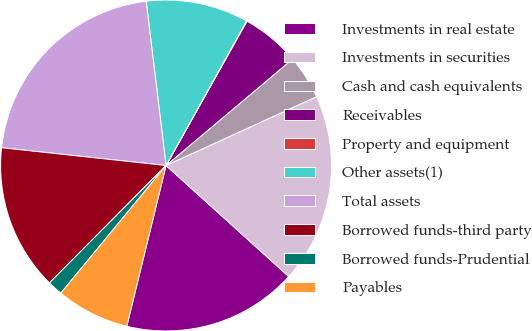<chart> <loc_0><loc_0><loc_500><loc_500><pie_chart><fcel>Investments in real estate<fcel>Investments in securities<fcel>Cash and cash equivalents<fcel>Receivables<fcel>Property and equipment<fcel>Other assets(1)<fcel>Total assets<fcel>Borrowed funds-third party<fcel>Borrowed funds-Prudential<fcel>Payables<nl><fcel>17.11%<fcel>18.53%<fcel>4.31%<fcel>5.73%<fcel>0.05%<fcel>10.0%<fcel>21.37%<fcel>14.27%<fcel>1.47%<fcel>7.16%<nl></chart> 